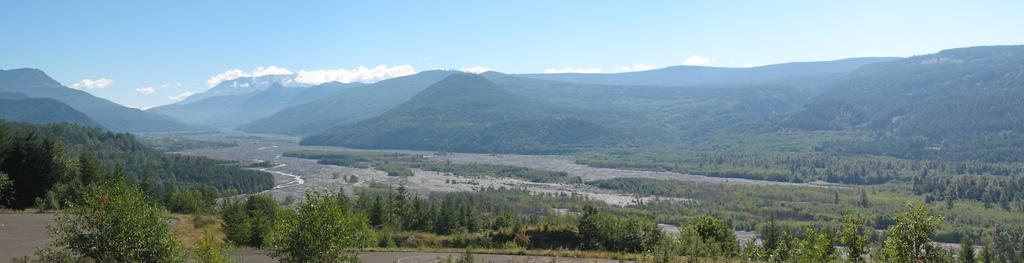What type of vegetation can be seen in the image? There are trees, plants, and grass visible in the image. What type of man-made structures can be seen in the image? There are roads visible in the image. What natural features can be seen in the background of the image? There are hills visible in the background of the image. What part of the natural environment is visible in the image? The sky is visible in the background of the image. Can you hear the bells ringing from the church in the image? There is no church or bells present in the image, so it is not possible to hear them ringing. Is there any magic happening in the image? There is no indication of any magic happening in the image. 